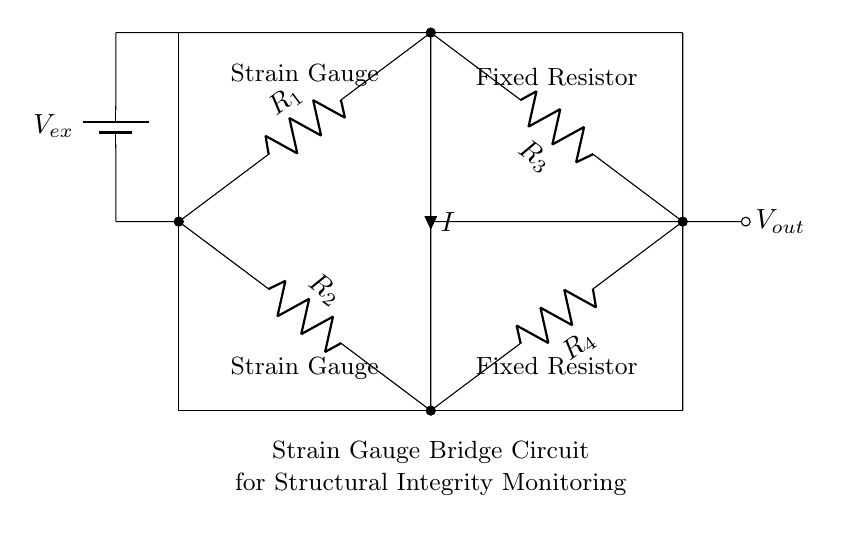What are the components used in this circuit? The circuit contains four resistors labeled R1, R2, R3, and R4, and a voltage source labeled Vex. These components form a strain gauge bridge circuit.
Answer: R1, R2, R3, R4, Vex What is the purpose of the strain gauges in this circuit? The strain gauges measure the deformation of a structure due to external forces. This change in resistance alters the output voltage, providing data for monitoring structural integrity.
Answer: Monitor structural integrity What type of circuit is depicted in this diagram? The diagram represents a strain gauge bridge circuit, which is used to measure small changes in resistance caused by strain.
Answer: Strain gauge bridge What is the output voltage source labeled as? The output voltage generated from the bridge circuit due to the imbalance caused by strain is denoted as Vout.
Answer: Vout How many resistors are present in this circuit? The circuit features four resistors, which are crucial for forming the bridge and ensuring accurate measurements of strain.
Answer: Four What current flows through the circuit? The current flowing through the circuit is labeled as I, which flows from the upper node to the lower node in the bridge arrangement.
Answer: I What is the significance of the fixed resistors in this circuit? The fixed resistors R3 and R4 provide stable reference points for measuring the changes in resistance from the strain gauges, ensuring accuracy in readings.
Answer: Accuracy of readings 